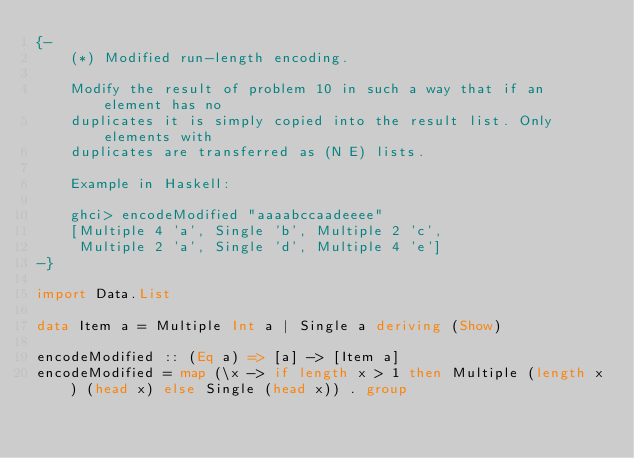Convert code to text. <code><loc_0><loc_0><loc_500><loc_500><_Haskell_>{-
    (*) Modified run-length encoding.

    Modify the result of problem 10 in such a way that if an element has no
    duplicates it is simply copied into the result list. Only elements with
    duplicates are transferred as (N E) lists.

    Example in Haskell:

    ghci> encodeModified "aaaabccaadeeee"
    [Multiple 4 'a', Single 'b', Multiple 2 'c',
     Multiple 2 'a', Single 'd', Multiple 4 'e']
-}

import Data.List

data Item a = Multiple Int a | Single a deriving (Show)

encodeModified :: (Eq a) => [a] -> [Item a]
encodeModified = map (\x -> if length x > 1 then Multiple (length x) (head x) else Single (head x)) . group
</code> 